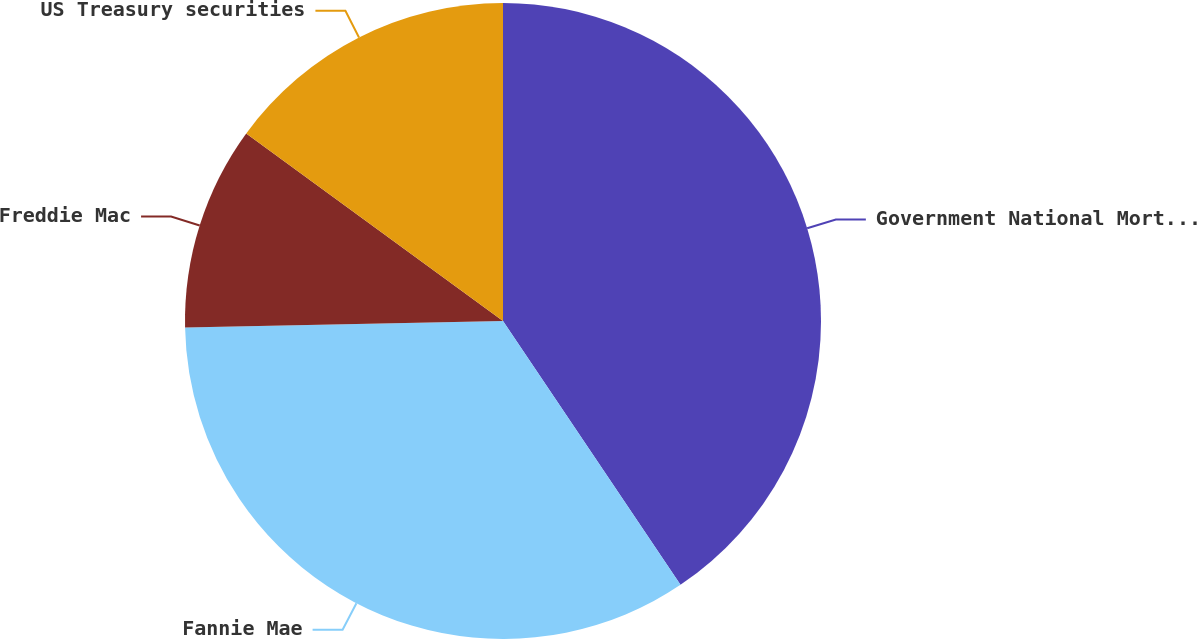Convert chart. <chart><loc_0><loc_0><loc_500><loc_500><pie_chart><fcel>Government National Mortgage<fcel>Fannie Mae<fcel>Freddie Mac<fcel>US Treasury securities<nl><fcel>40.58%<fcel>34.1%<fcel>10.37%<fcel>14.96%<nl></chart> 